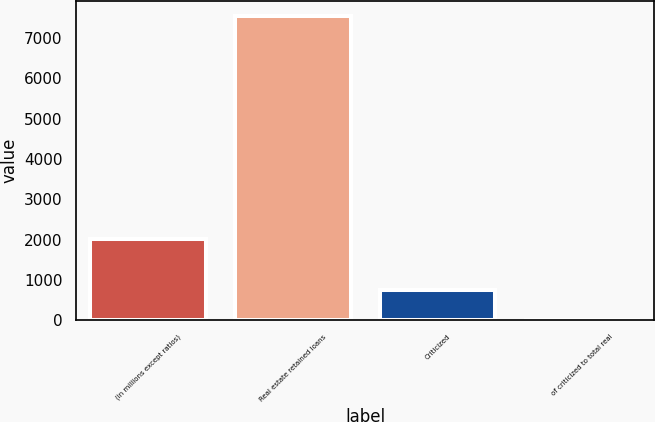<chart> <loc_0><loc_0><loc_500><loc_500><bar_chart><fcel>(in millions except ratios)<fcel>Real estate retained loans<fcel>Criticized<fcel>of criticized to total real<nl><fcel>2015<fcel>7548<fcel>755.69<fcel>0.99<nl></chart> 